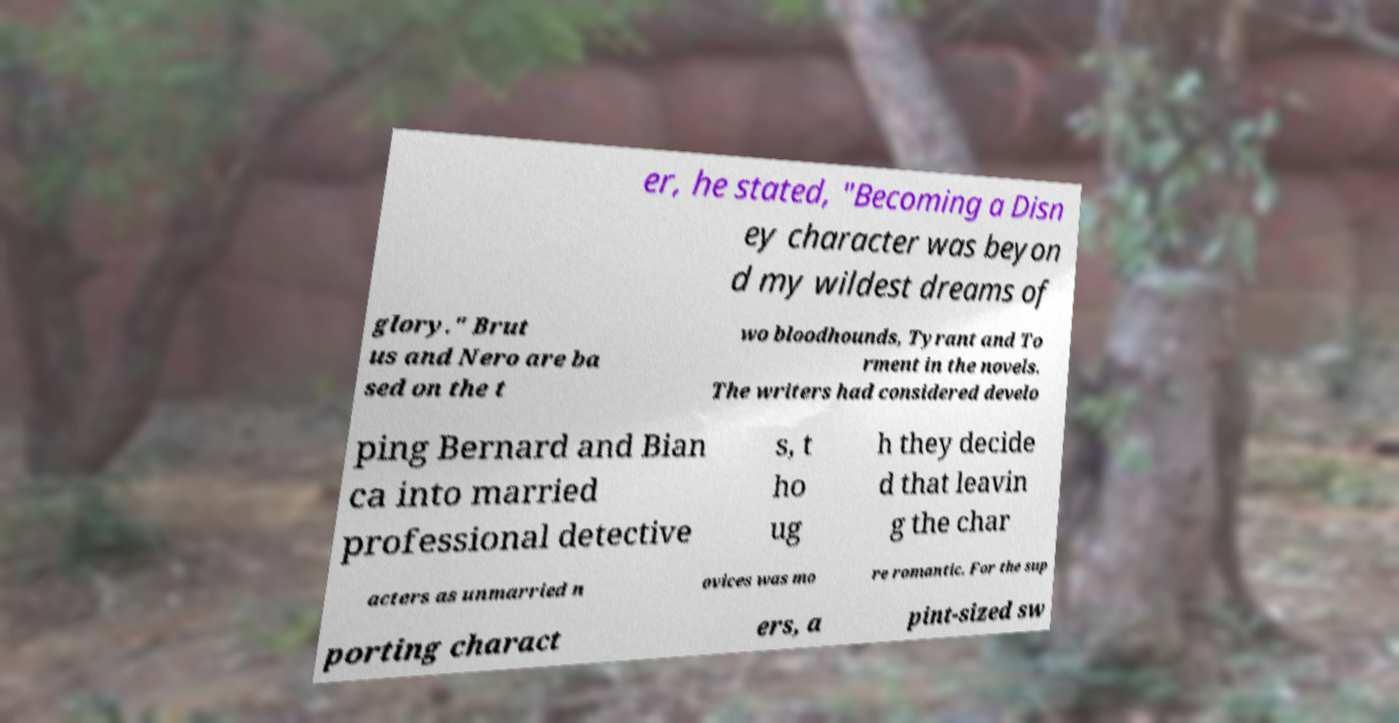Please identify and transcribe the text found in this image. er, he stated, "Becoming a Disn ey character was beyon d my wildest dreams of glory." Brut us and Nero are ba sed on the t wo bloodhounds, Tyrant and To rment in the novels. The writers had considered develo ping Bernard and Bian ca into married professional detective s, t ho ug h they decide d that leavin g the char acters as unmarried n ovices was mo re romantic. For the sup porting charact ers, a pint-sized sw 